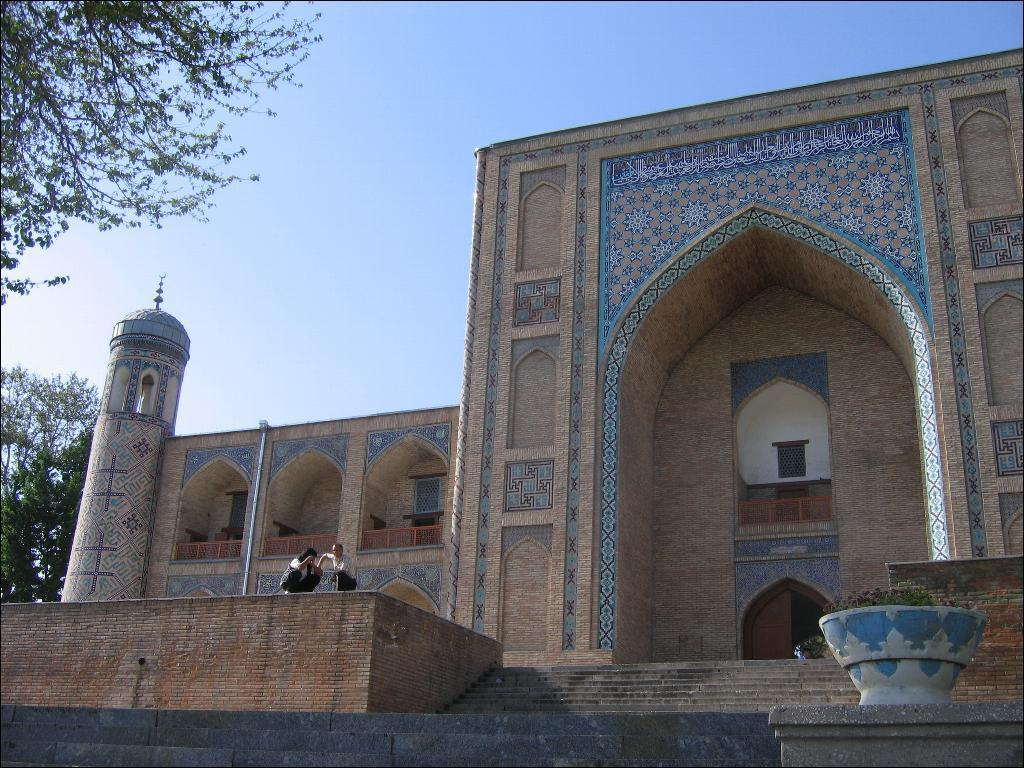What is the main subject of the image? The image shows the outside view of a monument. Are there any people in the image? Yes, there are two persons in the image. What type of natural elements can be seen in the image? Trees are present in the image. What is visible in the background of the image? The sky is visible in the image. What type of liquid can be seen flowing from the monument in the image? There is no liquid flowing from the monument in the image. 